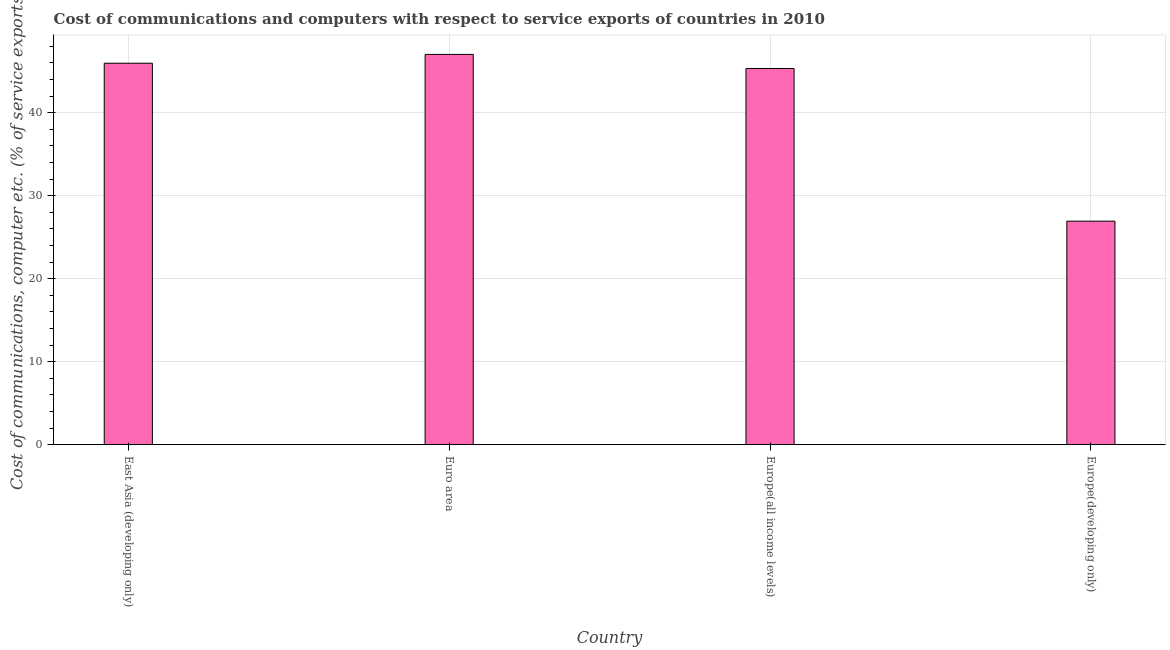Does the graph contain grids?
Provide a short and direct response. Yes. What is the title of the graph?
Ensure brevity in your answer.  Cost of communications and computers with respect to service exports of countries in 2010. What is the label or title of the X-axis?
Offer a very short reply. Country. What is the label or title of the Y-axis?
Make the answer very short. Cost of communications, computer etc. (% of service exports). What is the cost of communications and computer in East Asia (developing only)?
Your response must be concise. 45.97. Across all countries, what is the maximum cost of communications and computer?
Offer a very short reply. 47.04. Across all countries, what is the minimum cost of communications and computer?
Provide a short and direct response. 26.95. In which country was the cost of communications and computer minimum?
Make the answer very short. Europe(developing only). What is the sum of the cost of communications and computer?
Provide a short and direct response. 165.29. What is the difference between the cost of communications and computer in Europe(all income levels) and Europe(developing only)?
Offer a terse response. 18.39. What is the average cost of communications and computer per country?
Your answer should be compact. 41.32. What is the median cost of communications and computer?
Make the answer very short. 45.66. What is the ratio of the cost of communications and computer in Euro area to that in Europe(developing only)?
Give a very brief answer. 1.75. Is the cost of communications and computer in East Asia (developing only) less than that in Europe(developing only)?
Your answer should be very brief. No. Is the difference between the cost of communications and computer in Euro area and Europe(developing only) greater than the difference between any two countries?
Your response must be concise. Yes. What is the difference between the highest and the second highest cost of communications and computer?
Provide a succinct answer. 1.06. What is the difference between the highest and the lowest cost of communications and computer?
Ensure brevity in your answer.  20.09. In how many countries, is the cost of communications and computer greater than the average cost of communications and computer taken over all countries?
Your answer should be compact. 3. How many bars are there?
Keep it short and to the point. 4. What is the Cost of communications, computer etc. (% of service exports) in East Asia (developing only)?
Your response must be concise. 45.97. What is the Cost of communications, computer etc. (% of service exports) in Euro area?
Your answer should be very brief. 47.04. What is the Cost of communications, computer etc. (% of service exports) of Europe(all income levels)?
Ensure brevity in your answer.  45.34. What is the Cost of communications, computer etc. (% of service exports) of Europe(developing only)?
Your answer should be compact. 26.95. What is the difference between the Cost of communications, computer etc. (% of service exports) in East Asia (developing only) and Euro area?
Keep it short and to the point. -1.06. What is the difference between the Cost of communications, computer etc. (% of service exports) in East Asia (developing only) and Europe(all income levels)?
Your answer should be very brief. 0.63. What is the difference between the Cost of communications, computer etc. (% of service exports) in East Asia (developing only) and Europe(developing only)?
Your answer should be very brief. 19.03. What is the difference between the Cost of communications, computer etc. (% of service exports) in Euro area and Europe(all income levels)?
Offer a very short reply. 1.7. What is the difference between the Cost of communications, computer etc. (% of service exports) in Euro area and Europe(developing only)?
Your answer should be very brief. 20.09. What is the difference between the Cost of communications, computer etc. (% of service exports) in Europe(all income levels) and Europe(developing only)?
Keep it short and to the point. 18.39. What is the ratio of the Cost of communications, computer etc. (% of service exports) in East Asia (developing only) to that in Euro area?
Provide a succinct answer. 0.98. What is the ratio of the Cost of communications, computer etc. (% of service exports) in East Asia (developing only) to that in Europe(developing only)?
Make the answer very short. 1.71. What is the ratio of the Cost of communications, computer etc. (% of service exports) in Euro area to that in Europe(all income levels)?
Your response must be concise. 1.04. What is the ratio of the Cost of communications, computer etc. (% of service exports) in Euro area to that in Europe(developing only)?
Offer a very short reply. 1.75. What is the ratio of the Cost of communications, computer etc. (% of service exports) in Europe(all income levels) to that in Europe(developing only)?
Offer a terse response. 1.68. 